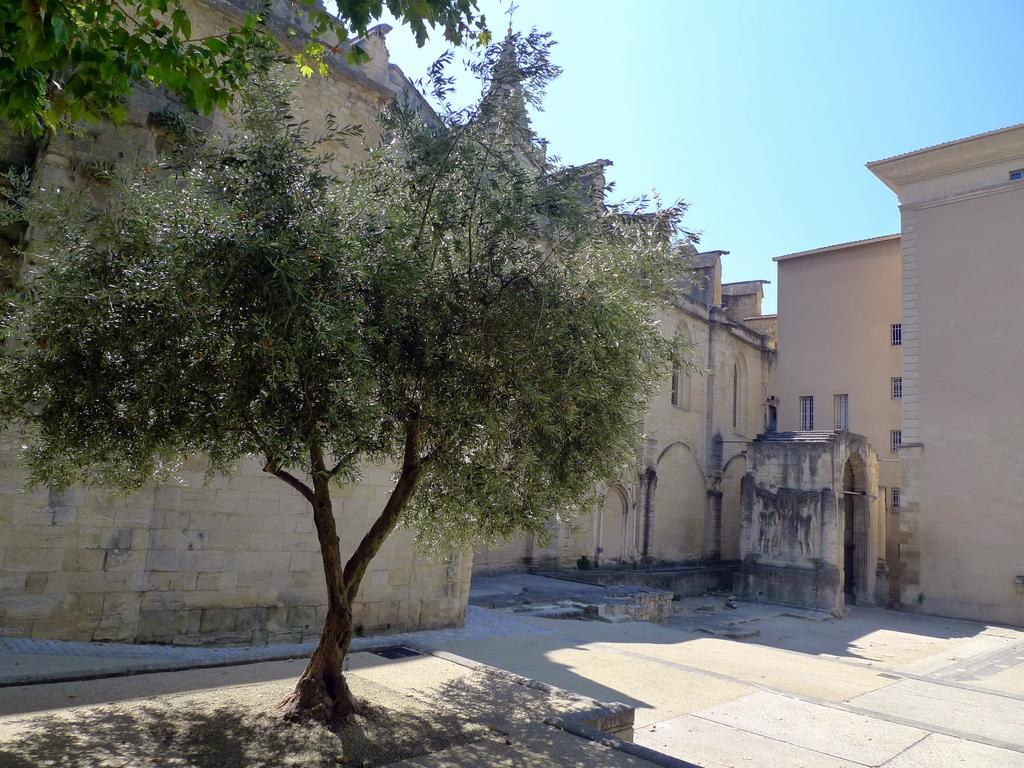What is located in the foreground of the image? There is a floor in the foreground of the image. What can be seen in the middle of the image? There is a tree and a building in the middle of the image. What symbol is present at the top of the image? There is a plus symbol at the top of the image. What is visible at the top of the image? The sky is visible at the top of the image. What type of jewel is depicted in the image? There is no jewel present in the image. What religious symbol can be seen in the image? There is no religious symbol present in the image. 